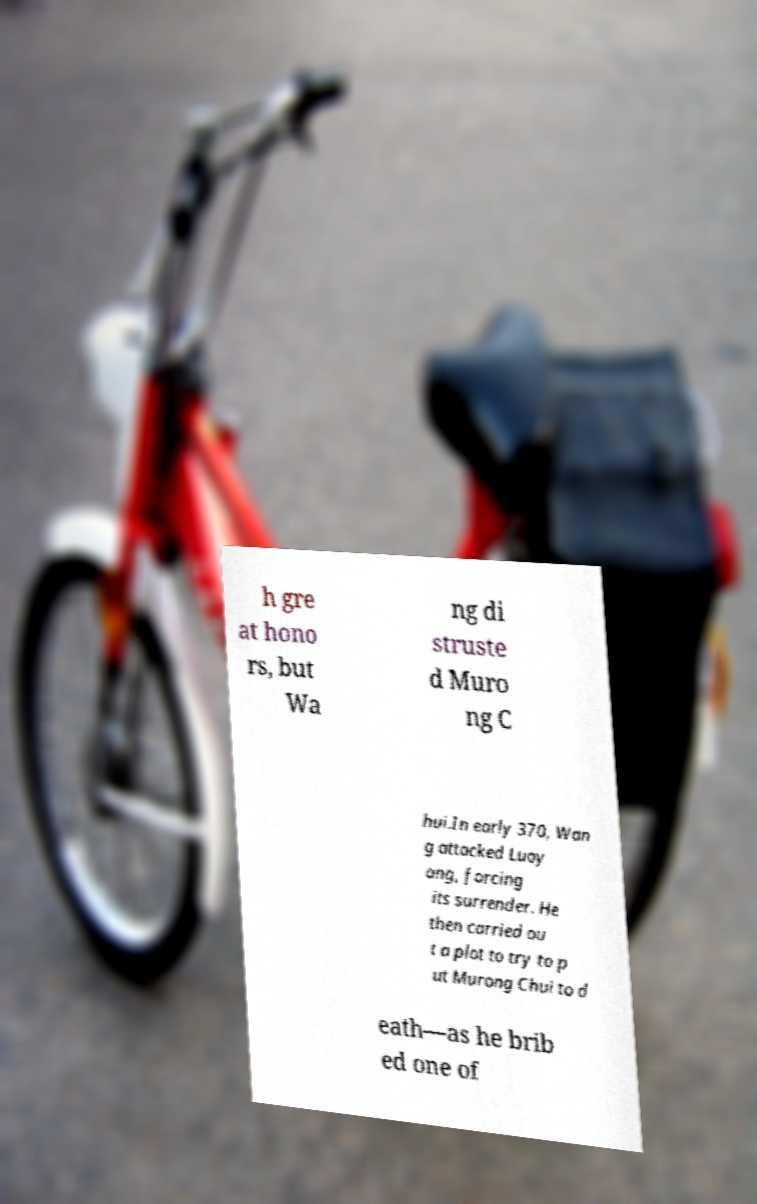There's text embedded in this image that I need extracted. Can you transcribe it verbatim? h gre at hono rs, but Wa ng di struste d Muro ng C hui.In early 370, Wan g attacked Luoy ang, forcing its surrender. He then carried ou t a plot to try to p ut Murong Chui to d eath—as he brib ed one of 